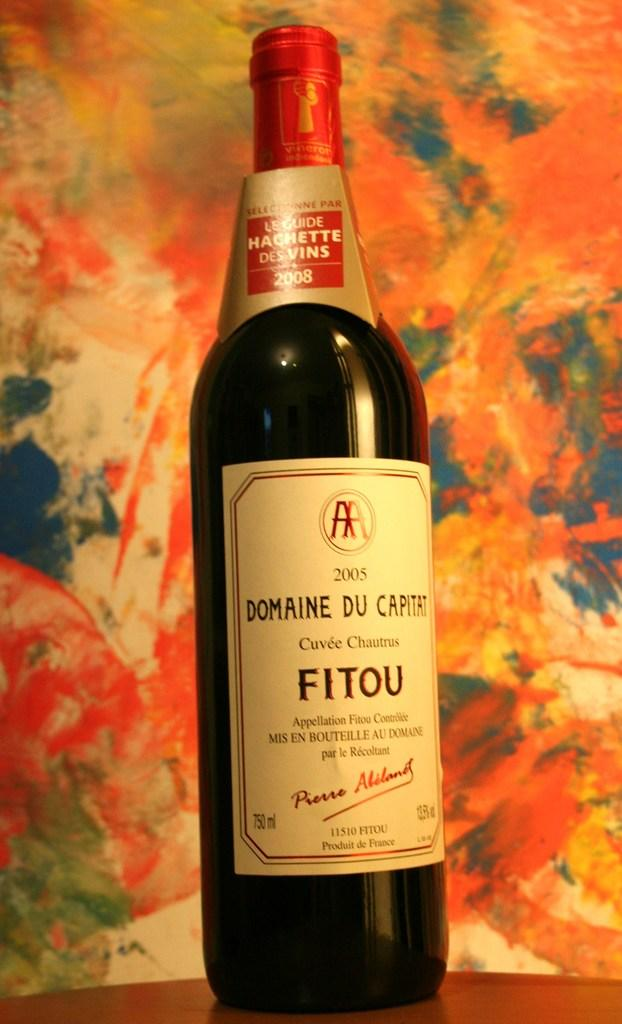<image>
Render a clear and concise summary of the photo. A bottle of Domaine Du Capitat wine stands in front of floral wallpaper. 